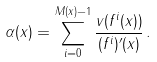<formula> <loc_0><loc_0><loc_500><loc_500>\alpha ( x ) = \sum _ { i = 0 } ^ { M ( x ) - 1 } \frac { v ( f ^ { i } ( x ) ) } { ( f ^ { i } ) ^ { \prime } ( x ) } \, .</formula> 